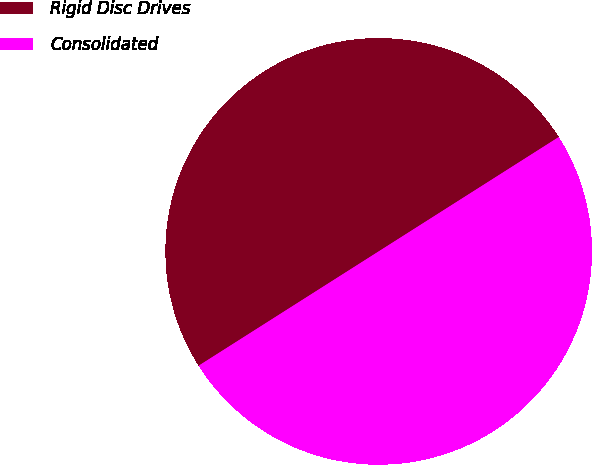<chart> <loc_0><loc_0><loc_500><loc_500><pie_chart><fcel>Rigid Disc Drives<fcel>Consolidated<nl><fcel>50.0%<fcel>50.0%<nl></chart> 